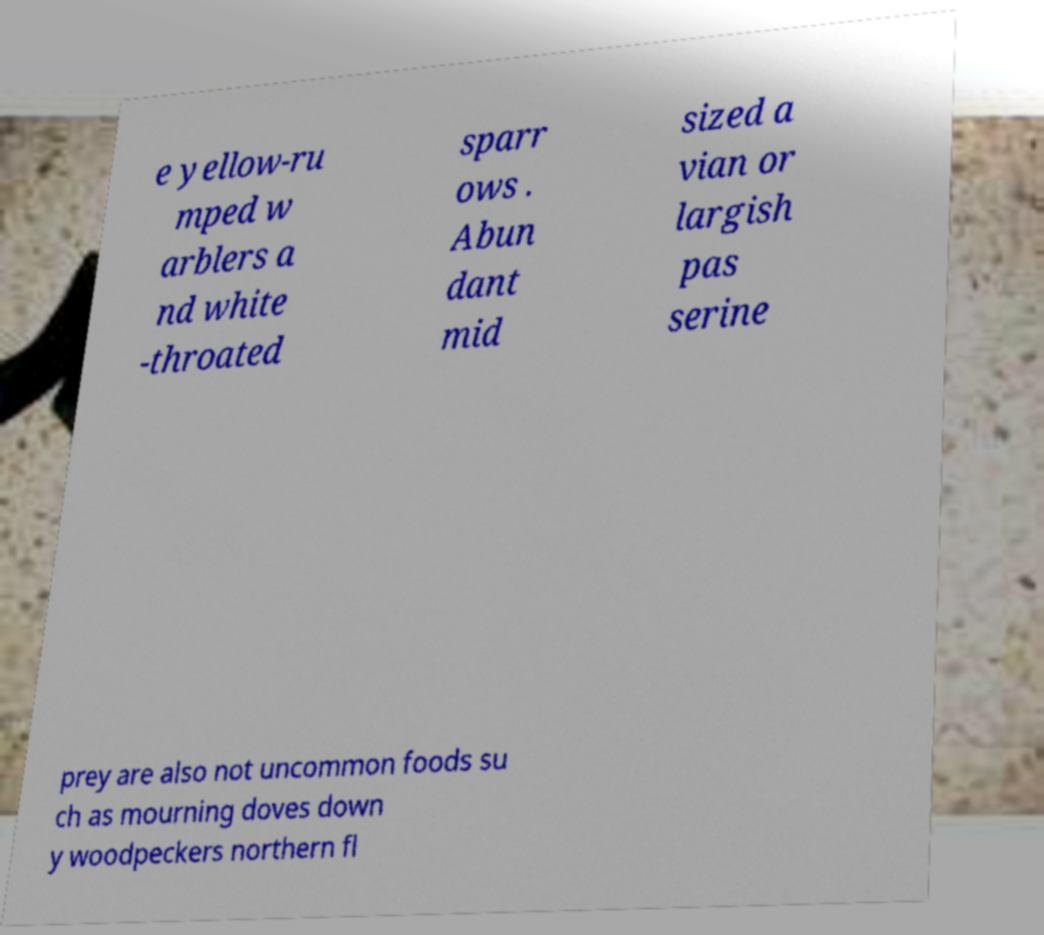Can you read and provide the text displayed in the image?This photo seems to have some interesting text. Can you extract and type it out for me? e yellow-ru mped w arblers a nd white -throated sparr ows . Abun dant mid sized a vian or largish pas serine prey are also not uncommon foods su ch as mourning doves down y woodpeckers northern fl 